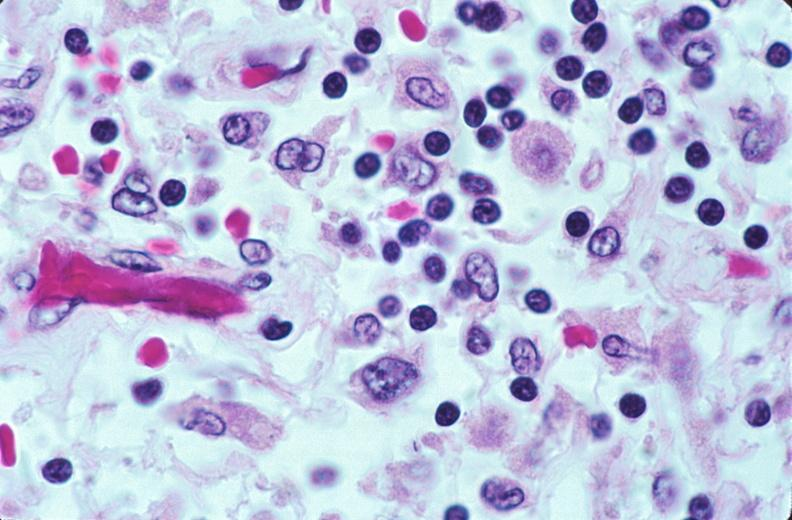does this photo show lymph nodes, nodular sclerosing hodgkins disease?
Answer the question using a single word or phrase. No 